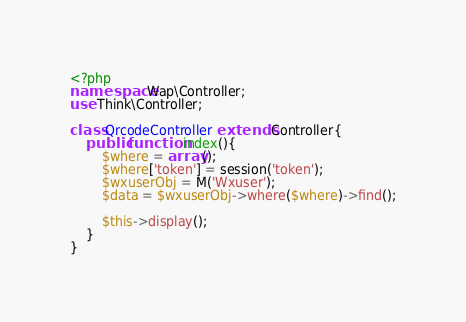Convert code to text. <code><loc_0><loc_0><loc_500><loc_500><_PHP_><?php
namespace Wap\Controller;
use Think\Controller;

class QrcodeController extends Controller{
	public function index(){
		$where = array();
		$where['token'] = session('token');
		$wxuserObj = M('Wxuser');
		$data = $wxuserObj->where($where)->find();
		
		$this->display();
	}
}</code> 